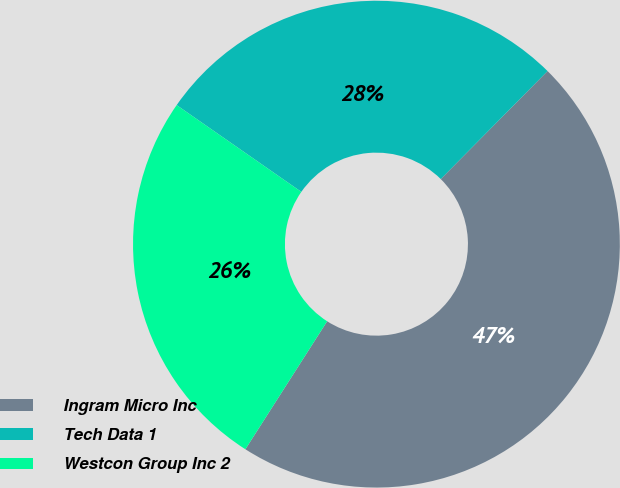<chart> <loc_0><loc_0><loc_500><loc_500><pie_chart><fcel>Ingram Micro Inc<fcel>Tech Data 1<fcel>Westcon Group Inc 2<nl><fcel>46.64%<fcel>27.73%<fcel>25.63%<nl></chart> 